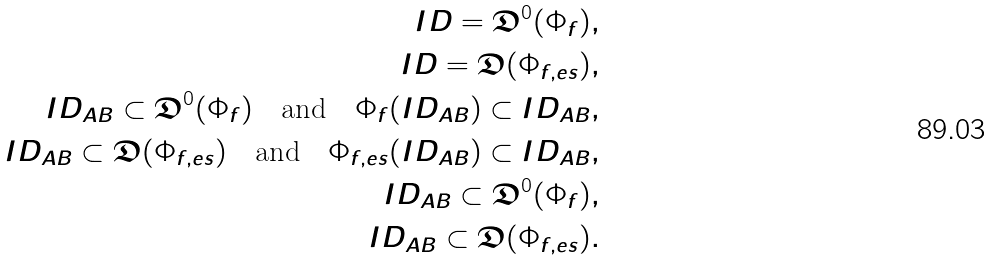<formula> <loc_0><loc_0><loc_500><loc_500>I D = \mathfrak D ^ { 0 } ( \Phi _ { f } ) , \\ I D = \mathfrak D ( \Phi _ { f , e s } ) , \\ I D _ { A B } \subset \mathfrak D ^ { 0 } ( \Phi _ { f } ) \quad \text {and} \quad \Phi _ { f } ( I D _ { A B } ) \subset I D _ { A B } , \\ I D _ { A B } \subset \mathfrak D ( \Phi _ { f , e s } ) \quad \text {and} \quad \Phi _ { f , e s } ( I D _ { A B } ) \subset I D _ { A B } , \\ I D _ { A B } \subset \mathfrak D ^ { 0 } ( \Phi _ { f } ) , \\ I D _ { A B } \subset \mathfrak D ( \Phi _ { f , e s } ) .</formula> 